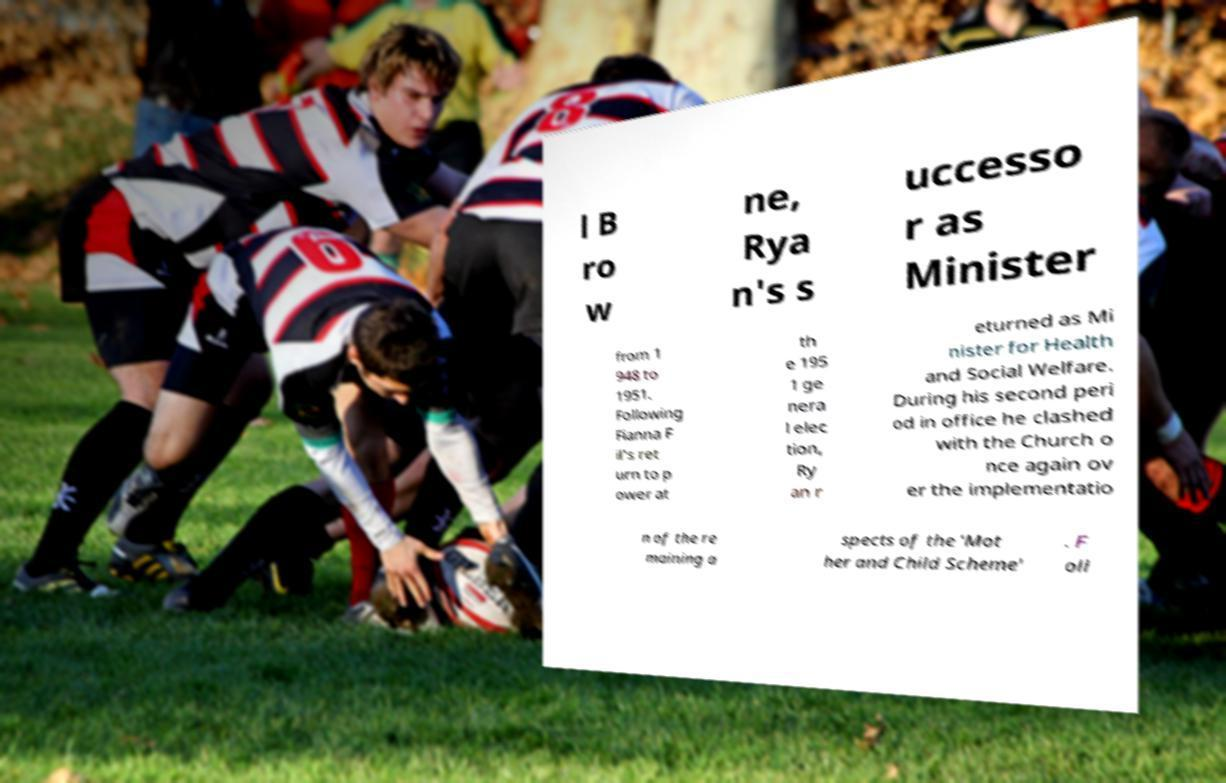Could you assist in decoding the text presented in this image and type it out clearly? l B ro w ne, Rya n's s uccesso r as Minister from 1 948 to 1951. Following Fianna F il's ret urn to p ower at th e 195 1 ge nera l elec tion, Ry an r eturned as Mi nister for Health and Social Welfare. During his second peri od in office he clashed with the Church o nce again ov er the implementatio n of the re maining a spects of the 'Mot her and Child Scheme' . F oll 